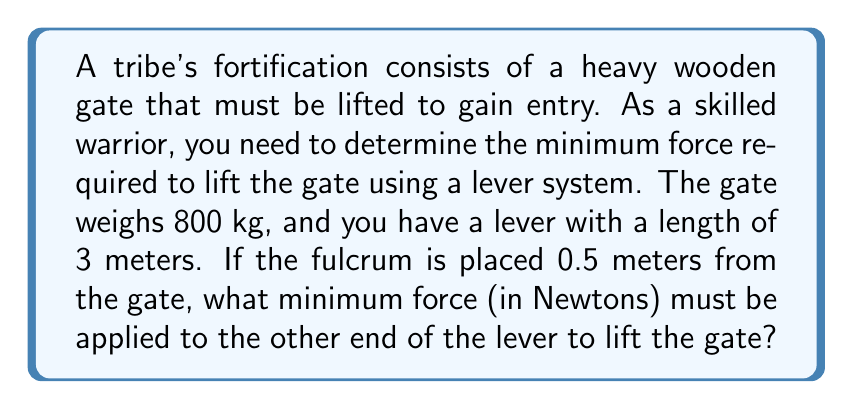What is the answer to this math problem? To solve this problem, we'll use the principle of leverage and the equation for mechanical advantage of a lever.

Step 1: Convert the gate's weight to force (in Newtons).
Force of gate = mass × acceleration due to gravity
$F_g = 800 \text{ kg} \times 9.8 \text{ m/s}^2 = 7840 \text{ N}$

Step 2: Identify the components of the lever system.
- Effort arm (distance from fulcrum to applied force): $l_e = 3 \text{ m} - 0.5 \text{ m} = 2.5 \text{ m}$
- Load arm (distance from fulcrum to gate): $l_l = 0.5 \text{ m}$

Step 3: Use the lever equation to determine the required force.
The lever equation states that:
$$\frac{F_e}{F_l} = \frac{l_l}{l_e}$$

Where:
$F_e$ = Effort force (unknown)
$F_l$ = Load force (7840 N)
$l_l$ = Load arm (0.5 m)
$l_e$ = Effort arm (2.5 m)

Rearranging the equation to solve for $F_e$:
$$F_e = F_l \times \frac{l_l}{l_e}$$

Step 4: Substitute the values and calculate.
$$F_e = 7840 \text{ N} \times \frac{0.5 \text{ m}}{2.5 \text{ m}} = 1568 \text{ N}$$

Therefore, the minimum force required to lift the gate using this lever system is 1568 N.
Answer: 1568 N 